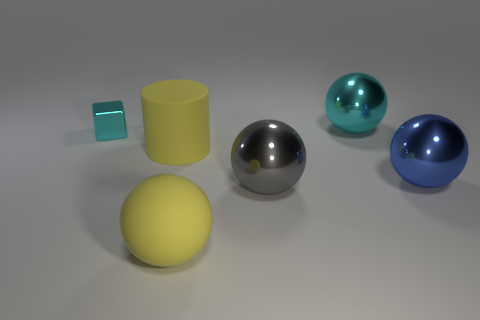Are there any other things that are the same size as the blue metallic object? Yes, the silver metallic sphere appears to be approximately the same size as the blue metallic sphere. 